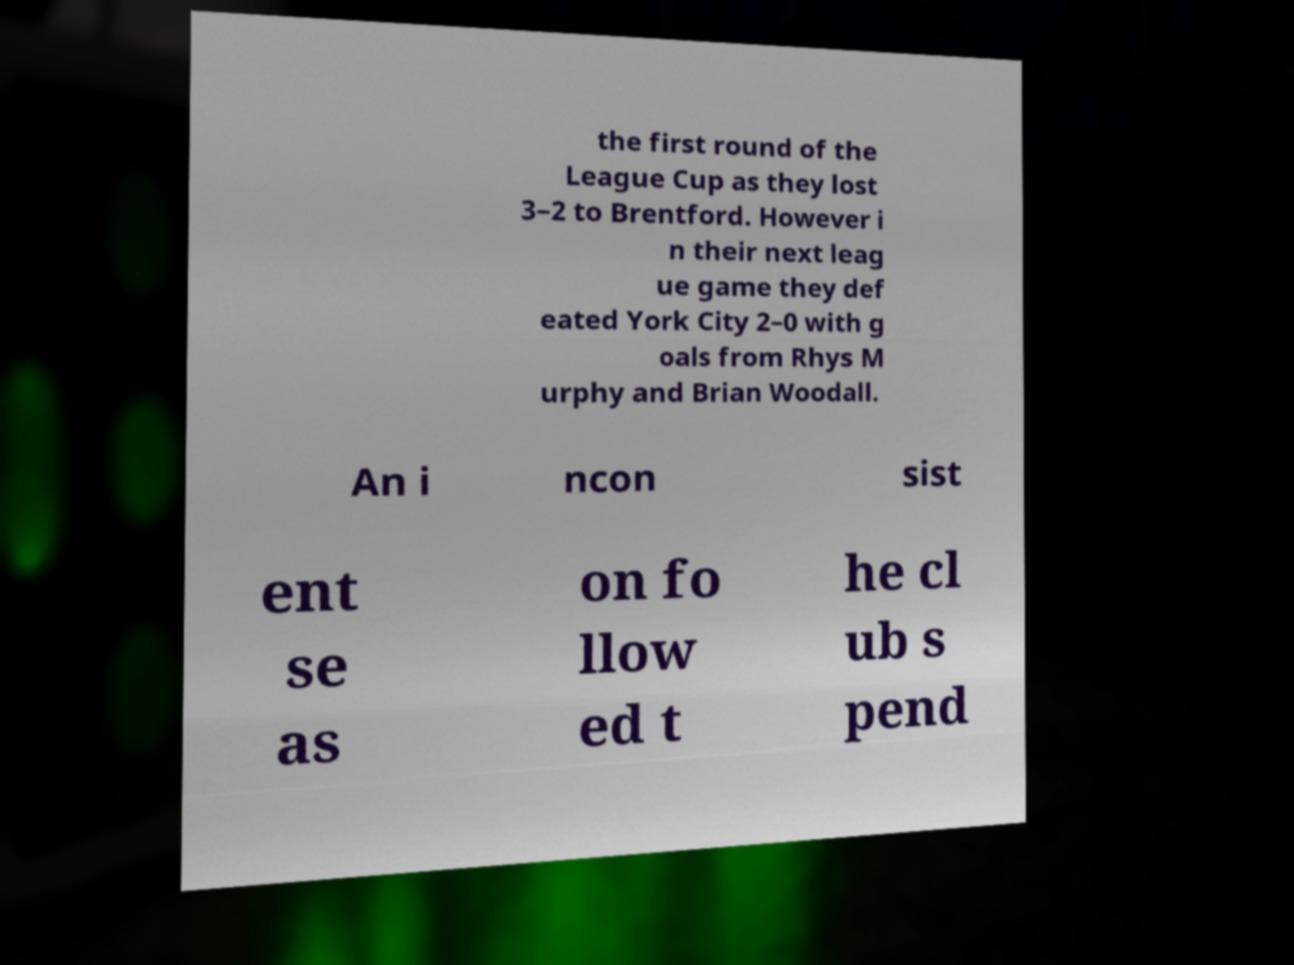Please read and relay the text visible in this image. What does it say? the first round of the League Cup as they lost 3–2 to Brentford. However i n their next leag ue game they def eated York City 2–0 with g oals from Rhys M urphy and Brian Woodall. An i ncon sist ent se as on fo llow ed t he cl ub s pend 